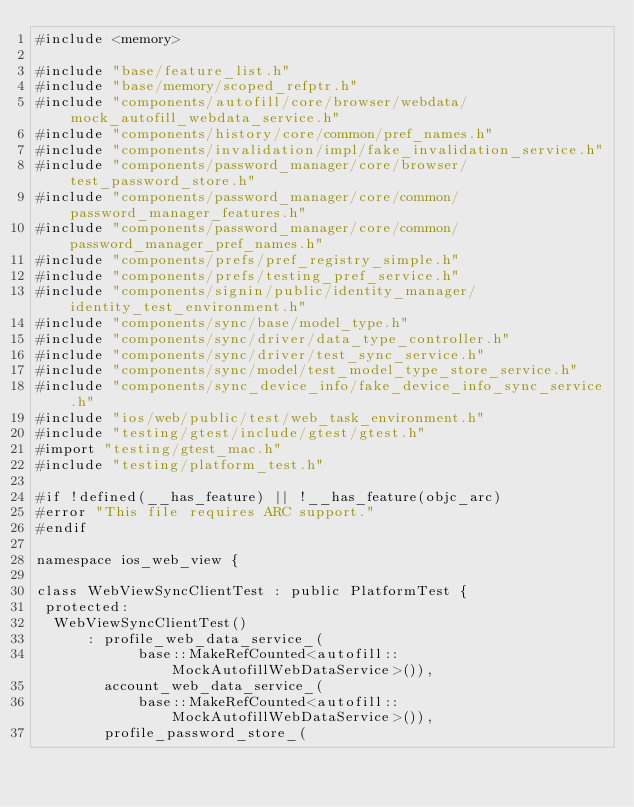<code> <loc_0><loc_0><loc_500><loc_500><_ObjectiveC_>#include <memory>

#include "base/feature_list.h"
#include "base/memory/scoped_refptr.h"
#include "components/autofill/core/browser/webdata/mock_autofill_webdata_service.h"
#include "components/history/core/common/pref_names.h"
#include "components/invalidation/impl/fake_invalidation_service.h"
#include "components/password_manager/core/browser/test_password_store.h"
#include "components/password_manager/core/common/password_manager_features.h"
#include "components/password_manager/core/common/password_manager_pref_names.h"
#include "components/prefs/pref_registry_simple.h"
#include "components/prefs/testing_pref_service.h"
#include "components/signin/public/identity_manager/identity_test_environment.h"
#include "components/sync/base/model_type.h"
#include "components/sync/driver/data_type_controller.h"
#include "components/sync/driver/test_sync_service.h"
#include "components/sync/model/test_model_type_store_service.h"
#include "components/sync_device_info/fake_device_info_sync_service.h"
#include "ios/web/public/test/web_task_environment.h"
#include "testing/gtest/include/gtest/gtest.h"
#import "testing/gtest_mac.h"
#include "testing/platform_test.h"

#if !defined(__has_feature) || !__has_feature(objc_arc)
#error "This file requires ARC support."
#endif

namespace ios_web_view {

class WebViewSyncClientTest : public PlatformTest {
 protected:
  WebViewSyncClientTest()
      : profile_web_data_service_(
            base::MakeRefCounted<autofill::MockAutofillWebDataService>()),
        account_web_data_service_(
            base::MakeRefCounted<autofill::MockAutofillWebDataService>()),
        profile_password_store_(</code> 